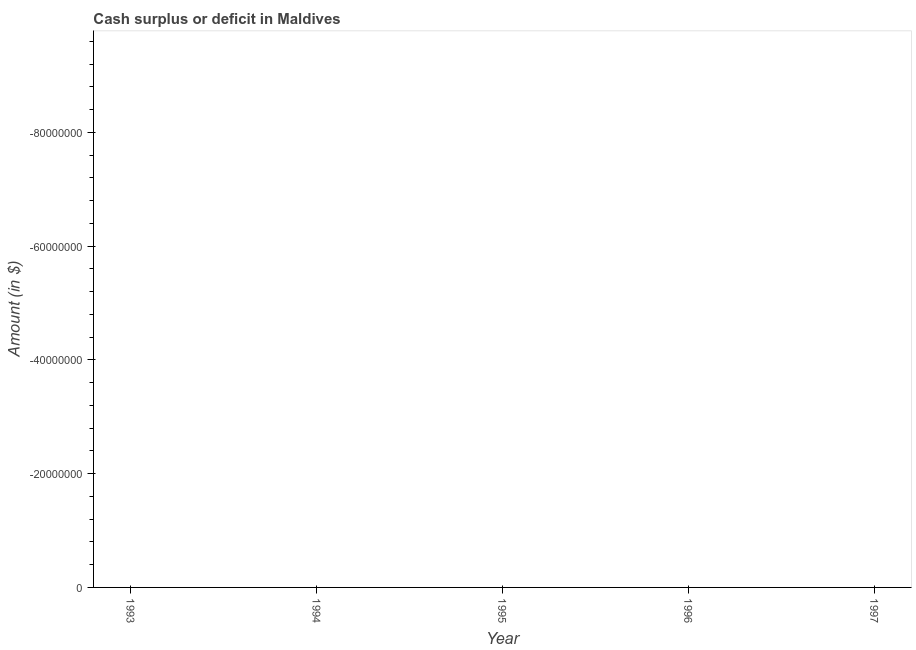What is the cash surplus or deficit in 1995?
Keep it short and to the point. 0. Across all years, what is the minimum cash surplus or deficit?
Provide a succinct answer. 0. What is the average cash surplus or deficit per year?
Ensure brevity in your answer.  0. What is the median cash surplus or deficit?
Your response must be concise. 0. In how many years, is the cash surplus or deficit greater than -12000000 $?
Make the answer very short. 0. In how many years, is the cash surplus or deficit greater than the average cash surplus or deficit taken over all years?
Your answer should be compact. 0. Does the cash surplus or deficit monotonically increase over the years?
Offer a terse response. No. How many years are there in the graph?
Provide a succinct answer. 5. What is the difference between two consecutive major ticks on the Y-axis?
Your response must be concise. 2.00e+07. Are the values on the major ticks of Y-axis written in scientific E-notation?
Give a very brief answer. No. Does the graph contain any zero values?
Ensure brevity in your answer.  Yes. Does the graph contain grids?
Provide a short and direct response. No. What is the title of the graph?
Offer a terse response. Cash surplus or deficit in Maldives. What is the label or title of the Y-axis?
Provide a short and direct response. Amount (in $). What is the Amount (in $) in 1994?
Your answer should be compact. 0. What is the Amount (in $) in 1997?
Provide a short and direct response. 0. 